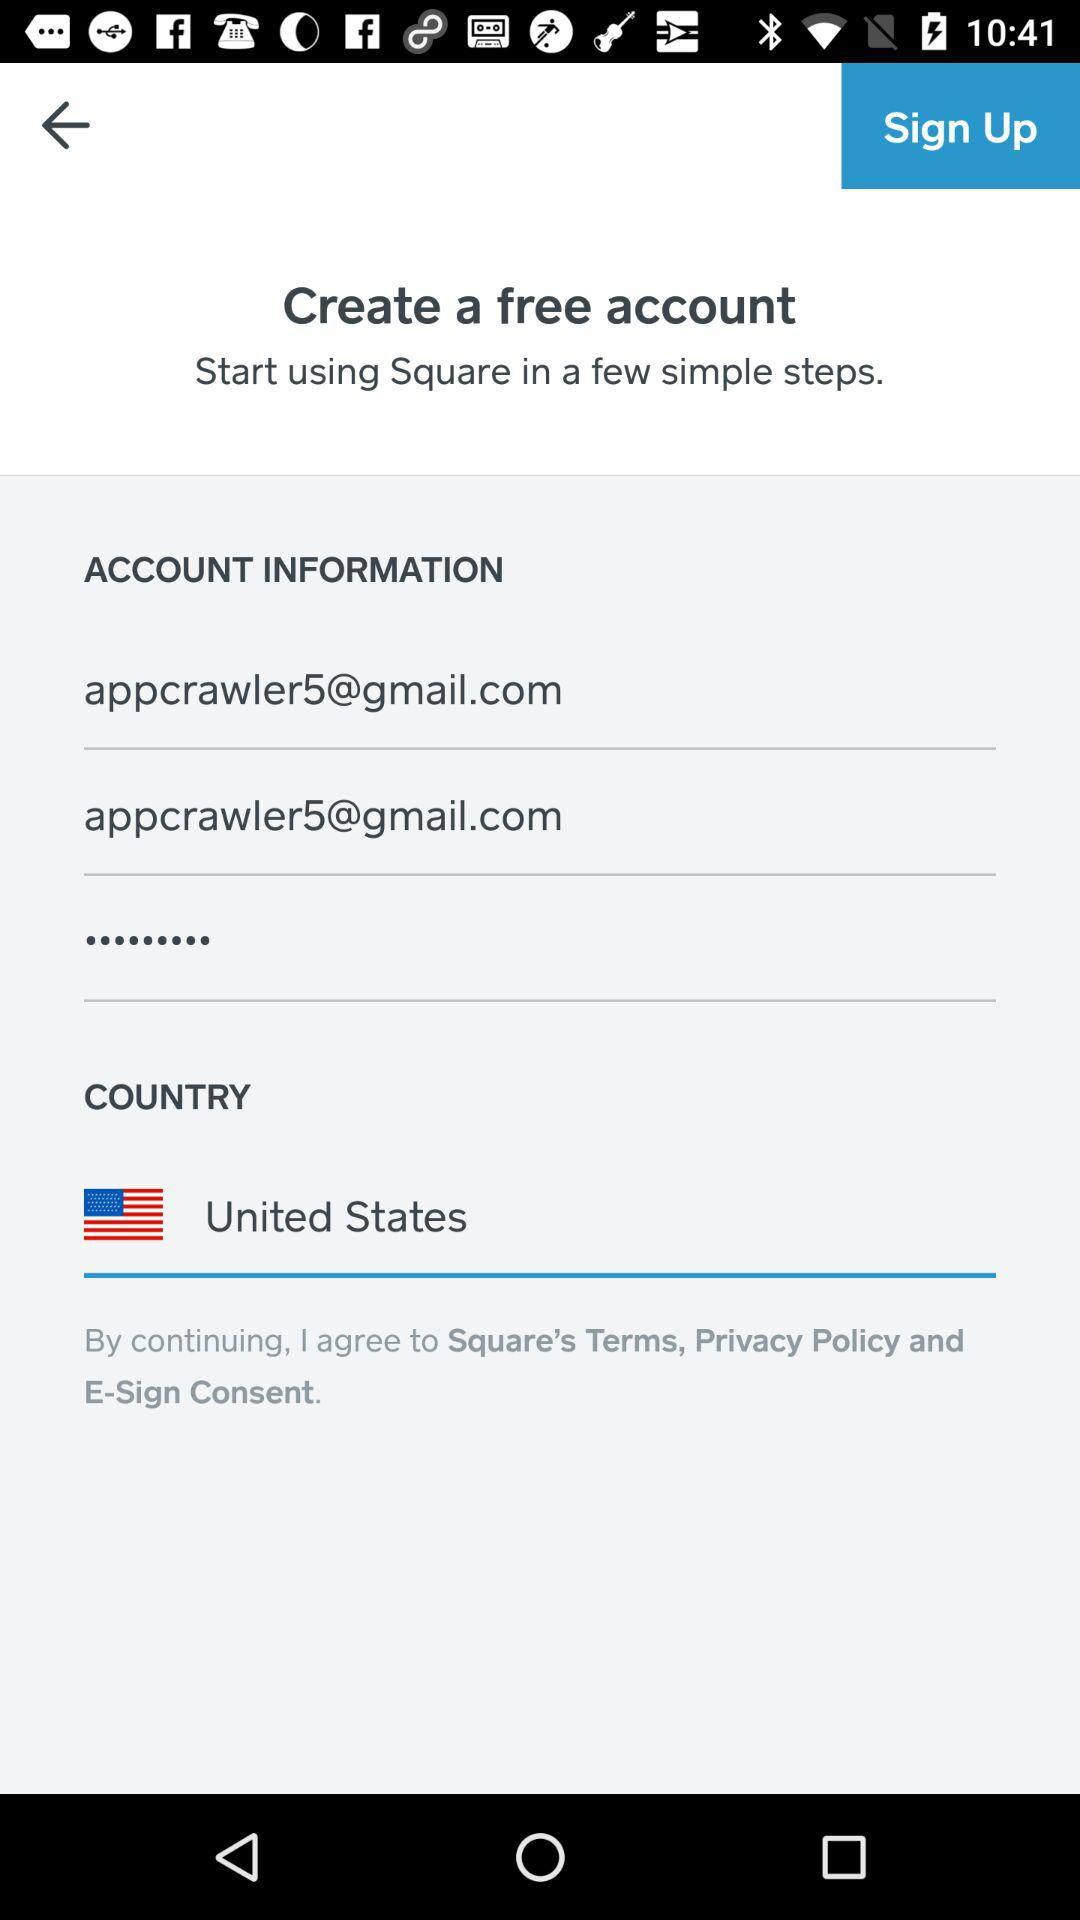What is the email id? The email id is appcrawler5@gmail.com. 